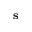<formula> <loc_0><loc_0><loc_500><loc_500>s</formula> 